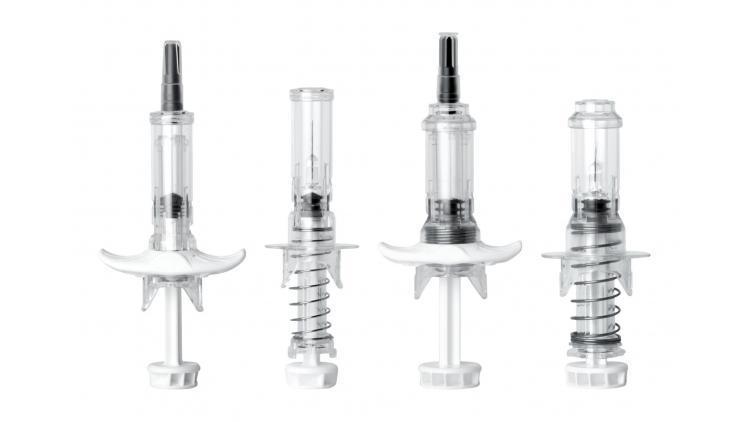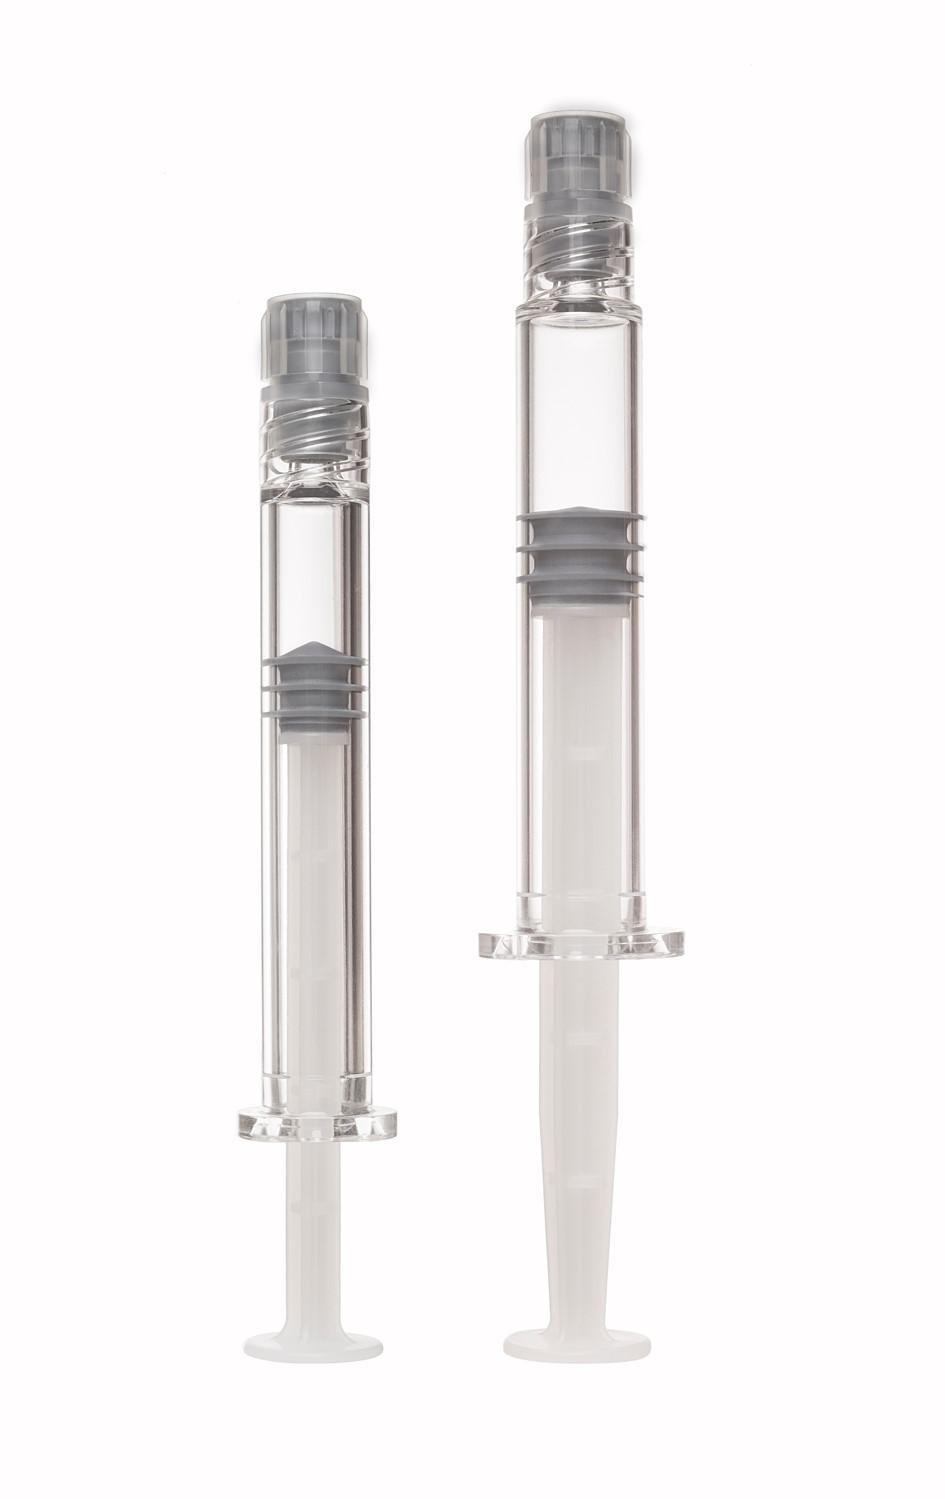The first image is the image on the left, the second image is the image on the right. Given the left and right images, does the statement "The image on the right has two syringes." hold true? Answer yes or no. Yes. 